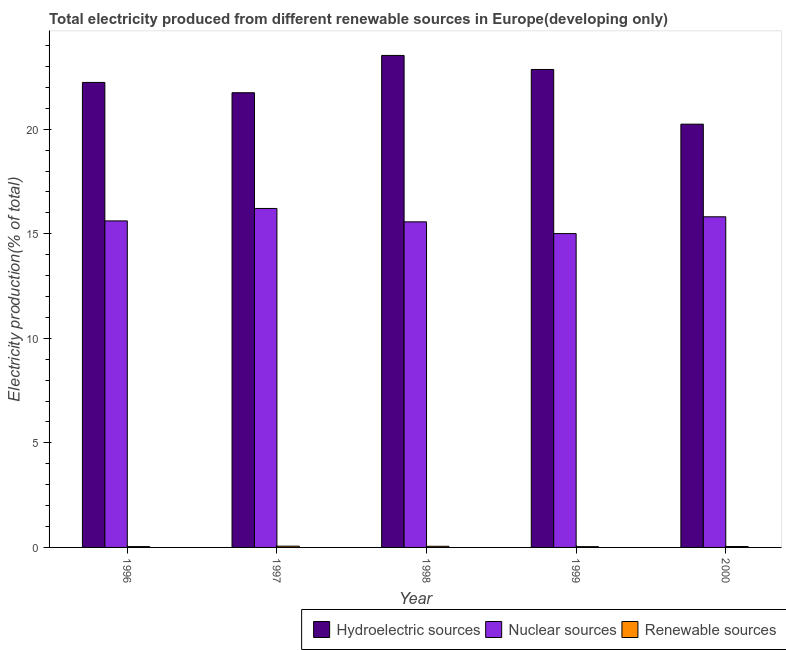How many different coloured bars are there?
Make the answer very short. 3. Are the number of bars per tick equal to the number of legend labels?
Your answer should be very brief. Yes. Are the number of bars on each tick of the X-axis equal?
Keep it short and to the point. Yes. How many bars are there on the 5th tick from the left?
Your answer should be very brief. 3. How many bars are there on the 3rd tick from the right?
Ensure brevity in your answer.  3. In how many cases, is the number of bars for a given year not equal to the number of legend labels?
Provide a short and direct response. 0. What is the percentage of electricity produced by renewable sources in 1996?
Your response must be concise. 0.04. Across all years, what is the maximum percentage of electricity produced by hydroelectric sources?
Provide a succinct answer. 23.53. Across all years, what is the minimum percentage of electricity produced by renewable sources?
Give a very brief answer. 0.04. What is the total percentage of electricity produced by renewable sources in the graph?
Make the answer very short. 0.24. What is the difference between the percentage of electricity produced by renewable sources in 1996 and that in 1997?
Ensure brevity in your answer.  -0.02. What is the difference between the percentage of electricity produced by renewable sources in 2000 and the percentage of electricity produced by nuclear sources in 1998?
Give a very brief answer. -0.01. What is the average percentage of electricity produced by nuclear sources per year?
Offer a very short reply. 15.64. In the year 1997, what is the difference between the percentage of electricity produced by renewable sources and percentage of electricity produced by hydroelectric sources?
Offer a terse response. 0. In how many years, is the percentage of electricity produced by renewable sources greater than 7 %?
Your response must be concise. 0. What is the ratio of the percentage of electricity produced by nuclear sources in 1996 to that in 2000?
Offer a very short reply. 0.99. What is the difference between the highest and the second highest percentage of electricity produced by hydroelectric sources?
Offer a terse response. 0.67. What is the difference between the highest and the lowest percentage of electricity produced by hydroelectric sources?
Keep it short and to the point. 3.29. In how many years, is the percentage of electricity produced by renewable sources greater than the average percentage of electricity produced by renewable sources taken over all years?
Your answer should be very brief. 2. Is the sum of the percentage of electricity produced by hydroelectric sources in 1996 and 1999 greater than the maximum percentage of electricity produced by renewable sources across all years?
Your answer should be compact. Yes. What does the 3rd bar from the left in 1999 represents?
Provide a succinct answer. Renewable sources. What does the 1st bar from the right in 2000 represents?
Your answer should be very brief. Renewable sources. Are all the bars in the graph horizontal?
Your answer should be compact. No. Are the values on the major ticks of Y-axis written in scientific E-notation?
Your answer should be very brief. No. Does the graph contain any zero values?
Make the answer very short. No. Does the graph contain grids?
Your answer should be very brief. No. Where does the legend appear in the graph?
Your answer should be compact. Bottom right. How are the legend labels stacked?
Give a very brief answer. Horizontal. What is the title of the graph?
Offer a terse response. Total electricity produced from different renewable sources in Europe(developing only). Does "Interest" appear as one of the legend labels in the graph?
Make the answer very short. No. What is the label or title of the Y-axis?
Offer a very short reply. Electricity production(% of total). What is the Electricity production(% of total) of Hydroelectric sources in 1996?
Offer a terse response. 22.24. What is the Electricity production(% of total) in Nuclear sources in 1996?
Provide a short and direct response. 15.61. What is the Electricity production(% of total) of Renewable sources in 1996?
Keep it short and to the point. 0.04. What is the Electricity production(% of total) of Hydroelectric sources in 1997?
Your response must be concise. 21.74. What is the Electricity production(% of total) of Nuclear sources in 1997?
Your answer should be compact. 16.21. What is the Electricity production(% of total) of Renewable sources in 1997?
Offer a very short reply. 0.06. What is the Electricity production(% of total) of Hydroelectric sources in 1998?
Your answer should be compact. 23.53. What is the Electricity production(% of total) of Nuclear sources in 1998?
Make the answer very short. 15.57. What is the Electricity production(% of total) of Renewable sources in 1998?
Provide a succinct answer. 0.05. What is the Electricity production(% of total) of Hydroelectric sources in 1999?
Your response must be concise. 22.86. What is the Electricity production(% of total) in Nuclear sources in 1999?
Offer a very short reply. 15.01. What is the Electricity production(% of total) of Renewable sources in 1999?
Keep it short and to the point. 0.04. What is the Electricity production(% of total) of Hydroelectric sources in 2000?
Your answer should be very brief. 20.24. What is the Electricity production(% of total) of Nuclear sources in 2000?
Offer a terse response. 15.81. What is the Electricity production(% of total) of Renewable sources in 2000?
Your response must be concise. 0.04. Across all years, what is the maximum Electricity production(% of total) of Hydroelectric sources?
Your answer should be very brief. 23.53. Across all years, what is the maximum Electricity production(% of total) in Nuclear sources?
Your answer should be very brief. 16.21. Across all years, what is the maximum Electricity production(% of total) in Renewable sources?
Keep it short and to the point. 0.06. Across all years, what is the minimum Electricity production(% of total) of Hydroelectric sources?
Your response must be concise. 20.24. Across all years, what is the minimum Electricity production(% of total) of Nuclear sources?
Your response must be concise. 15.01. Across all years, what is the minimum Electricity production(% of total) in Renewable sources?
Your response must be concise. 0.04. What is the total Electricity production(% of total) in Hydroelectric sources in the graph?
Your answer should be compact. 110.61. What is the total Electricity production(% of total) in Nuclear sources in the graph?
Provide a succinct answer. 78.21. What is the total Electricity production(% of total) in Renewable sources in the graph?
Offer a terse response. 0.24. What is the difference between the Electricity production(% of total) in Hydroelectric sources in 1996 and that in 1997?
Your answer should be compact. 0.49. What is the difference between the Electricity production(% of total) of Nuclear sources in 1996 and that in 1997?
Your response must be concise. -0.59. What is the difference between the Electricity production(% of total) in Renewable sources in 1996 and that in 1997?
Make the answer very short. -0.02. What is the difference between the Electricity production(% of total) of Hydroelectric sources in 1996 and that in 1998?
Your answer should be very brief. -1.29. What is the difference between the Electricity production(% of total) of Nuclear sources in 1996 and that in 1998?
Your response must be concise. 0.05. What is the difference between the Electricity production(% of total) in Renewable sources in 1996 and that in 1998?
Provide a succinct answer. -0.01. What is the difference between the Electricity production(% of total) of Hydroelectric sources in 1996 and that in 1999?
Offer a very short reply. -0.62. What is the difference between the Electricity production(% of total) in Nuclear sources in 1996 and that in 1999?
Your answer should be compact. 0.61. What is the difference between the Electricity production(% of total) of Renewable sources in 1996 and that in 1999?
Make the answer very short. 0. What is the difference between the Electricity production(% of total) of Hydroelectric sources in 1996 and that in 2000?
Your response must be concise. 2. What is the difference between the Electricity production(% of total) in Nuclear sources in 1996 and that in 2000?
Keep it short and to the point. -0.2. What is the difference between the Electricity production(% of total) of Renewable sources in 1996 and that in 2000?
Your answer should be compact. -0. What is the difference between the Electricity production(% of total) in Hydroelectric sources in 1997 and that in 1998?
Your response must be concise. -1.78. What is the difference between the Electricity production(% of total) of Nuclear sources in 1997 and that in 1998?
Provide a succinct answer. 0.64. What is the difference between the Electricity production(% of total) in Renewable sources in 1997 and that in 1998?
Your response must be concise. 0.01. What is the difference between the Electricity production(% of total) of Hydroelectric sources in 1997 and that in 1999?
Your response must be concise. -1.11. What is the difference between the Electricity production(% of total) of Nuclear sources in 1997 and that in 1999?
Your response must be concise. 1.2. What is the difference between the Electricity production(% of total) of Renewable sources in 1997 and that in 1999?
Make the answer very short. 0.02. What is the difference between the Electricity production(% of total) in Hydroelectric sources in 1997 and that in 2000?
Ensure brevity in your answer.  1.5. What is the difference between the Electricity production(% of total) in Nuclear sources in 1997 and that in 2000?
Provide a succinct answer. 0.4. What is the difference between the Electricity production(% of total) of Renewable sources in 1997 and that in 2000?
Give a very brief answer. 0.02. What is the difference between the Electricity production(% of total) in Hydroelectric sources in 1998 and that in 1999?
Your answer should be very brief. 0.67. What is the difference between the Electricity production(% of total) of Nuclear sources in 1998 and that in 1999?
Keep it short and to the point. 0.56. What is the difference between the Electricity production(% of total) in Renewable sources in 1998 and that in 1999?
Make the answer very short. 0.02. What is the difference between the Electricity production(% of total) of Hydroelectric sources in 1998 and that in 2000?
Your answer should be compact. 3.29. What is the difference between the Electricity production(% of total) in Nuclear sources in 1998 and that in 2000?
Provide a short and direct response. -0.24. What is the difference between the Electricity production(% of total) in Renewable sources in 1998 and that in 2000?
Provide a short and direct response. 0.01. What is the difference between the Electricity production(% of total) of Hydroelectric sources in 1999 and that in 2000?
Offer a very short reply. 2.61. What is the difference between the Electricity production(% of total) in Nuclear sources in 1999 and that in 2000?
Make the answer very short. -0.8. What is the difference between the Electricity production(% of total) in Renewable sources in 1999 and that in 2000?
Provide a short and direct response. -0.01. What is the difference between the Electricity production(% of total) in Hydroelectric sources in 1996 and the Electricity production(% of total) in Nuclear sources in 1997?
Your answer should be very brief. 6.03. What is the difference between the Electricity production(% of total) of Hydroelectric sources in 1996 and the Electricity production(% of total) of Renewable sources in 1997?
Keep it short and to the point. 22.18. What is the difference between the Electricity production(% of total) of Nuclear sources in 1996 and the Electricity production(% of total) of Renewable sources in 1997?
Offer a very short reply. 15.55. What is the difference between the Electricity production(% of total) of Hydroelectric sources in 1996 and the Electricity production(% of total) of Nuclear sources in 1998?
Your answer should be compact. 6.67. What is the difference between the Electricity production(% of total) of Hydroelectric sources in 1996 and the Electricity production(% of total) of Renewable sources in 1998?
Offer a very short reply. 22.18. What is the difference between the Electricity production(% of total) of Nuclear sources in 1996 and the Electricity production(% of total) of Renewable sources in 1998?
Offer a terse response. 15.56. What is the difference between the Electricity production(% of total) in Hydroelectric sources in 1996 and the Electricity production(% of total) in Nuclear sources in 1999?
Your answer should be compact. 7.23. What is the difference between the Electricity production(% of total) in Hydroelectric sources in 1996 and the Electricity production(% of total) in Renewable sources in 1999?
Provide a succinct answer. 22.2. What is the difference between the Electricity production(% of total) of Nuclear sources in 1996 and the Electricity production(% of total) of Renewable sources in 1999?
Offer a very short reply. 15.58. What is the difference between the Electricity production(% of total) of Hydroelectric sources in 1996 and the Electricity production(% of total) of Nuclear sources in 2000?
Offer a terse response. 6.43. What is the difference between the Electricity production(% of total) of Hydroelectric sources in 1996 and the Electricity production(% of total) of Renewable sources in 2000?
Your response must be concise. 22.19. What is the difference between the Electricity production(% of total) in Nuclear sources in 1996 and the Electricity production(% of total) in Renewable sources in 2000?
Ensure brevity in your answer.  15.57. What is the difference between the Electricity production(% of total) of Hydroelectric sources in 1997 and the Electricity production(% of total) of Nuclear sources in 1998?
Give a very brief answer. 6.17. What is the difference between the Electricity production(% of total) in Hydroelectric sources in 1997 and the Electricity production(% of total) in Renewable sources in 1998?
Keep it short and to the point. 21.69. What is the difference between the Electricity production(% of total) of Nuclear sources in 1997 and the Electricity production(% of total) of Renewable sources in 1998?
Offer a very short reply. 16.16. What is the difference between the Electricity production(% of total) of Hydroelectric sources in 1997 and the Electricity production(% of total) of Nuclear sources in 1999?
Provide a succinct answer. 6.74. What is the difference between the Electricity production(% of total) in Hydroelectric sources in 1997 and the Electricity production(% of total) in Renewable sources in 1999?
Provide a succinct answer. 21.71. What is the difference between the Electricity production(% of total) in Nuclear sources in 1997 and the Electricity production(% of total) in Renewable sources in 1999?
Offer a terse response. 16.17. What is the difference between the Electricity production(% of total) of Hydroelectric sources in 1997 and the Electricity production(% of total) of Nuclear sources in 2000?
Make the answer very short. 5.93. What is the difference between the Electricity production(% of total) in Hydroelectric sources in 1997 and the Electricity production(% of total) in Renewable sources in 2000?
Offer a terse response. 21.7. What is the difference between the Electricity production(% of total) of Nuclear sources in 1997 and the Electricity production(% of total) of Renewable sources in 2000?
Keep it short and to the point. 16.17. What is the difference between the Electricity production(% of total) of Hydroelectric sources in 1998 and the Electricity production(% of total) of Nuclear sources in 1999?
Give a very brief answer. 8.52. What is the difference between the Electricity production(% of total) of Hydroelectric sources in 1998 and the Electricity production(% of total) of Renewable sources in 1999?
Give a very brief answer. 23.49. What is the difference between the Electricity production(% of total) of Nuclear sources in 1998 and the Electricity production(% of total) of Renewable sources in 1999?
Your response must be concise. 15.53. What is the difference between the Electricity production(% of total) in Hydroelectric sources in 1998 and the Electricity production(% of total) in Nuclear sources in 2000?
Offer a very short reply. 7.72. What is the difference between the Electricity production(% of total) of Hydroelectric sources in 1998 and the Electricity production(% of total) of Renewable sources in 2000?
Your answer should be compact. 23.48. What is the difference between the Electricity production(% of total) of Nuclear sources in 1998 and the Electricity production(% of total) of Renewable sources in 2000?
Your answer should be very brief. 15.53. What is the difference between the Electricity production(% of total) of Hydroelectric sources in 1999 and the Electricity production(% of total) of Nuclear sources in 2000?
Provide a short and direct response. 7.04. What is the difference between the Electricity production(% of total) of Hydroelectric sources in 1999 and the Electricity production(% of total) of Renewable sources in 2000?
Offer a terse response. 22.81. What is the difference between the Electricity production(% of total) of Nuclear sources in 1999 and the Electricity production(% of total) of Renewable sources in 2000?
Offer a very short reply. 14.97. What is the average Electricity production(% of total) in Hydroelectric sources per year?
Your answer should be compact. 22.12. What is the average Electricity production(% of total) of Nuclear sources per year?
Your response must be concise. 15.64. What is the average Electricity production(% of total) of Renewable sources per year?
Give a very brief answer. 0.05. In the year 1996, what is the difference between the Electricity production(% of total) in Hydroelectric sources and Electricity production(% of total) in Nuclear sources?
Your answer should be compact. 6.62. In the year 1996, what is the difference between the Electricity production(% of total) of Hydroelectric sources and Electricity production(% of total) of Renewable sources?
Your answer should be compact. 22.2. In the year 1996, what is the difference between the Electricity production(% of total) of Nuclear sources and Electricity production(% of total) of Renewable sources?
Provide a succinct answer. 15.57. In the year 1997, what is the difference between the Electricity production(% of total) in Hydroelectric sources and Electricity production(% of total) in Nuclear sources?
Provide a succinct answer. 5.53. In the year 1997, what is the difference between the Electricity production(% of total) of Hydroelectric sources and Electricity production(% of total) of Renewable sources?
Keep it short and to the point. 21.68. In the year 1997, what is the difference between the Electricity production(% of total) of Nuclear sources and Electricity production(% of total) of Renewable sources?
Your response must be concise. 16.15. In the year 1998, what is the difference between the Electricity production(% of total) of Hydroelectric sources and Electricity production(% of total) of Nuclear sources?
Give a very brief answer. 7.96. In the year 1998, what is the difference between the Electricity production(% of total) of Hydroelectric sources and Electricity production(% of total) of Renewable sources?
Provide a succinct answer. 23.47. In the year 1998, what is the difference between the Electricity production(% of total) in Nuclear sources and Electricity production(% of total) in Renewable sources?
Offer a terse response. 15.52. In the year 1999, what is the difference between the Electricity production(% of total) in Hydroelectric sources and Electricity production(% of total) in Nuclear sources?
Keep it short and to the point. 7.85. In the year 1999, what is the difference between the Electricity production(% of total) of Hydroelectric sources and Electricity production(% of total) of Renewable sources?
Offer a very short reply. 22.82. In the year 1999, what is the difference between the Electricity production(% of total) in Nuclear sources and Electricity production(% of total) in Renewable sources?
Your response must be concise. 14.97. In the year 2000, what is the difference between the Electricity production(% of total) in Hydroelectric sources and Electricity production(% of total) in Nuclear sources?
Provide a succinct answer. 4.43. In the year 2000, what is the difference between the Electricity production(% of total) of Hydroelectric sources and Electricity production(% of total) of Renewable sources?
Your response must be concise. 20.2. In the year 2000, what is the difference between the Electricity production(% of total) in Nuclear sources and Electricity production(% of total) in Renewable sources?
Offer a very short reply. 15.77. What is the ratio of the Electricity production(% of total) of Hydroelectric sources in 1996 to that in 1997?
Your answer should be compact. 1.02. What is the ratio of the Electricity production(% of total) in Nuclear sources in 1996 to that in 1997?
Keep it short and to the point. 0.96. What is the ratio of the Electricity production(% of total) in Renewable sources in 1996 to that in 1997?
Ensure brevity in your answer.  0.66. What is the ratio of the Electricity production(% of total) of Hydroelectric sources in 1996 to that in 1998?
Your response must be concise. 0.95. What is the ratio of the Electricity production(% of total) in Renewable sources in 1996 to that in 1998?
Your answer should be compact. 0.74. What is the ratio of the Electricity production(% of total) of Hydroelectric sources in 1996 to that in 1999?
Offer a very short reply. 0.97. What is the ratio of the Electricity production(% of total) in Nuclear sources in 1996 to that in 1999?
Ensure brevity in your answer.  1.04. What is the ratio of the Electricity production(% of total) in Renewable sources in 1996 to that in 1999?
Your answer should be very brief. 1.07. What is the ratio of the Electricity production(% of total) of Hydroelectric sources in 1996 to that in 2000?
Your response must be concise. 1.1. What is the ratio of the Electricity production(% of total) of Nuclear sources in 1996 to that in 2000?
Make the answer very short. 0.99. What is the ratio of the Electricity production(% of total) of Renewable sources in 1996 to that in 2000?
Your answer should be very brief. 0.93. What is the ratio of the Electricity production(% of total) of Hydroelectric sources in 1997 to that in 1998?
Give a very brief answer. 0.92. What is the ratio of the Electricity production(% of total) in Nuclear sources in 1997 to that in 1998?
Keep it short and to the point. 1.04. What is the ratio of the Electricity production(% of total) of Renewable sources in 1997 to that in 1998?
Keep it short and to the point. 1.11. What is the ratio of the Electricity production(% of total) in Hydroelectric sources in 1997 to that in 1999?
Your answer should be very brief. 0.95. What is the ratio of the Electricity production(% of total) of Nuclear sources in 1997 to that in 1999?
Keep it short and to the point. 1.08. What is the ratio of the Electricity production(% of total) in Renewable sources in 1997 to that in 1999?
Give a very brief answer. 1.61. What is the ratio of the Electricity production(% of total) of Hydroelectric sources in 1997 to that in 2000?
Offer a very short reply. 1.07. What is the ratio of the Electricity production(% of total) in Nuclear sources in 1997 to that in 2000?
Provide a succinct answer. 1.03. What is the ratio of the Electricity production(% of total) in Renewable sources in 1997 to that in 2000?
Provide a succinct answer. 1.4. What is the ratio of the Electricity production(% of total) of Hydroelectric sources in 1998 to that in 1999?
Offer a terse response. 1.03. What is the ratio of the Electricity production(% of total) in Nuclear sources in 1998 to that in 1999?
Offer a terse response. 1.04. What is the ratio of the Electricity production(% of total) of Renewable sources in 1998 to that in 1999?
Keep it short and to the point. 1.44. What is the ratio of the Electricity production(% of total) of Hydroelectric sources in 1998 to that in 2000?
Your response must be concise. 1.16. What is the ratio of the Electricity production(% of total) of Nuclear sources in 1998 to that in 2000?
Offer a terse response. 0.98. What is the ratio of the Electricity production(% of total) in Renewable sources in 1998 to that in 2000?
Provide a short and direct response. 1.26. What is the ratio of the Electricity production(% of total) of Hydroelectric sources in 1999 to that in 2000?
Make the answer very short. 1.13. What is the ratio of the Electricity production(% of total) of Nuclear sources in 1999 to that in 2000?
Keep it short and to the point. 0.95. What is the ratio of the Electricity production(% of total) in Renewable sources in 1999 to that in 2000?
Ensure brevity in your answer.  0.87. What is the difference between the highest and the second highest Electricity production(% of total) of Hydroelectric sources?
Keep it short and to the point. 0.67. What is the difference between the highest and the second highest Electricity production(% of total) of Nuclear sources?
Your answer should be compact. 0.4. What is the difference between the highest and the second highest Electricity production(% of total) in Renewable sources?
Your answer should be compact. 0.01. What is the difference between the highest and the lowest Electricity production(% of total) in Hydroelectric sources?
Offer a terse response. 3.29. What is the difference between the highest and the lowest Electricity production(% of total) in Nuclear sources?
Your answer should be very brief. 1.2. What is the difference between the highest and the lowest Electricity production(% of total) in Renewable sources?
Offer a terse response. 0.02. 